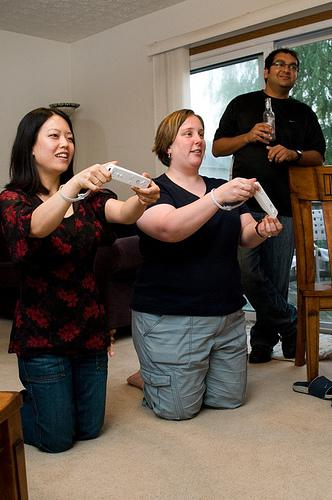Question: who is in the photo?
Choices:
A. Three men.
B. A family.
C. Two ladies and a man.
D. A man and woman.
Answer with the letter. Answer: C Question: how are the ladies positioned?
Choices:
A. Sitting.
B. Standing.
C. Kneeling.
D. Lying.
Answer with the letter. Answer: C Question: why is the man holding a bottle?
Choices:
A. Feeding a baby.
B. He is a waiter.
C. He is thirsty.
D. He is drinking beer.
Answer with the letter. Answer: D Question: what are the ladies holding?
Choices:
A. Purses.
B. Flowers.
C. Babies.
D. Controllers.
Answer with the letter. Answer: D 